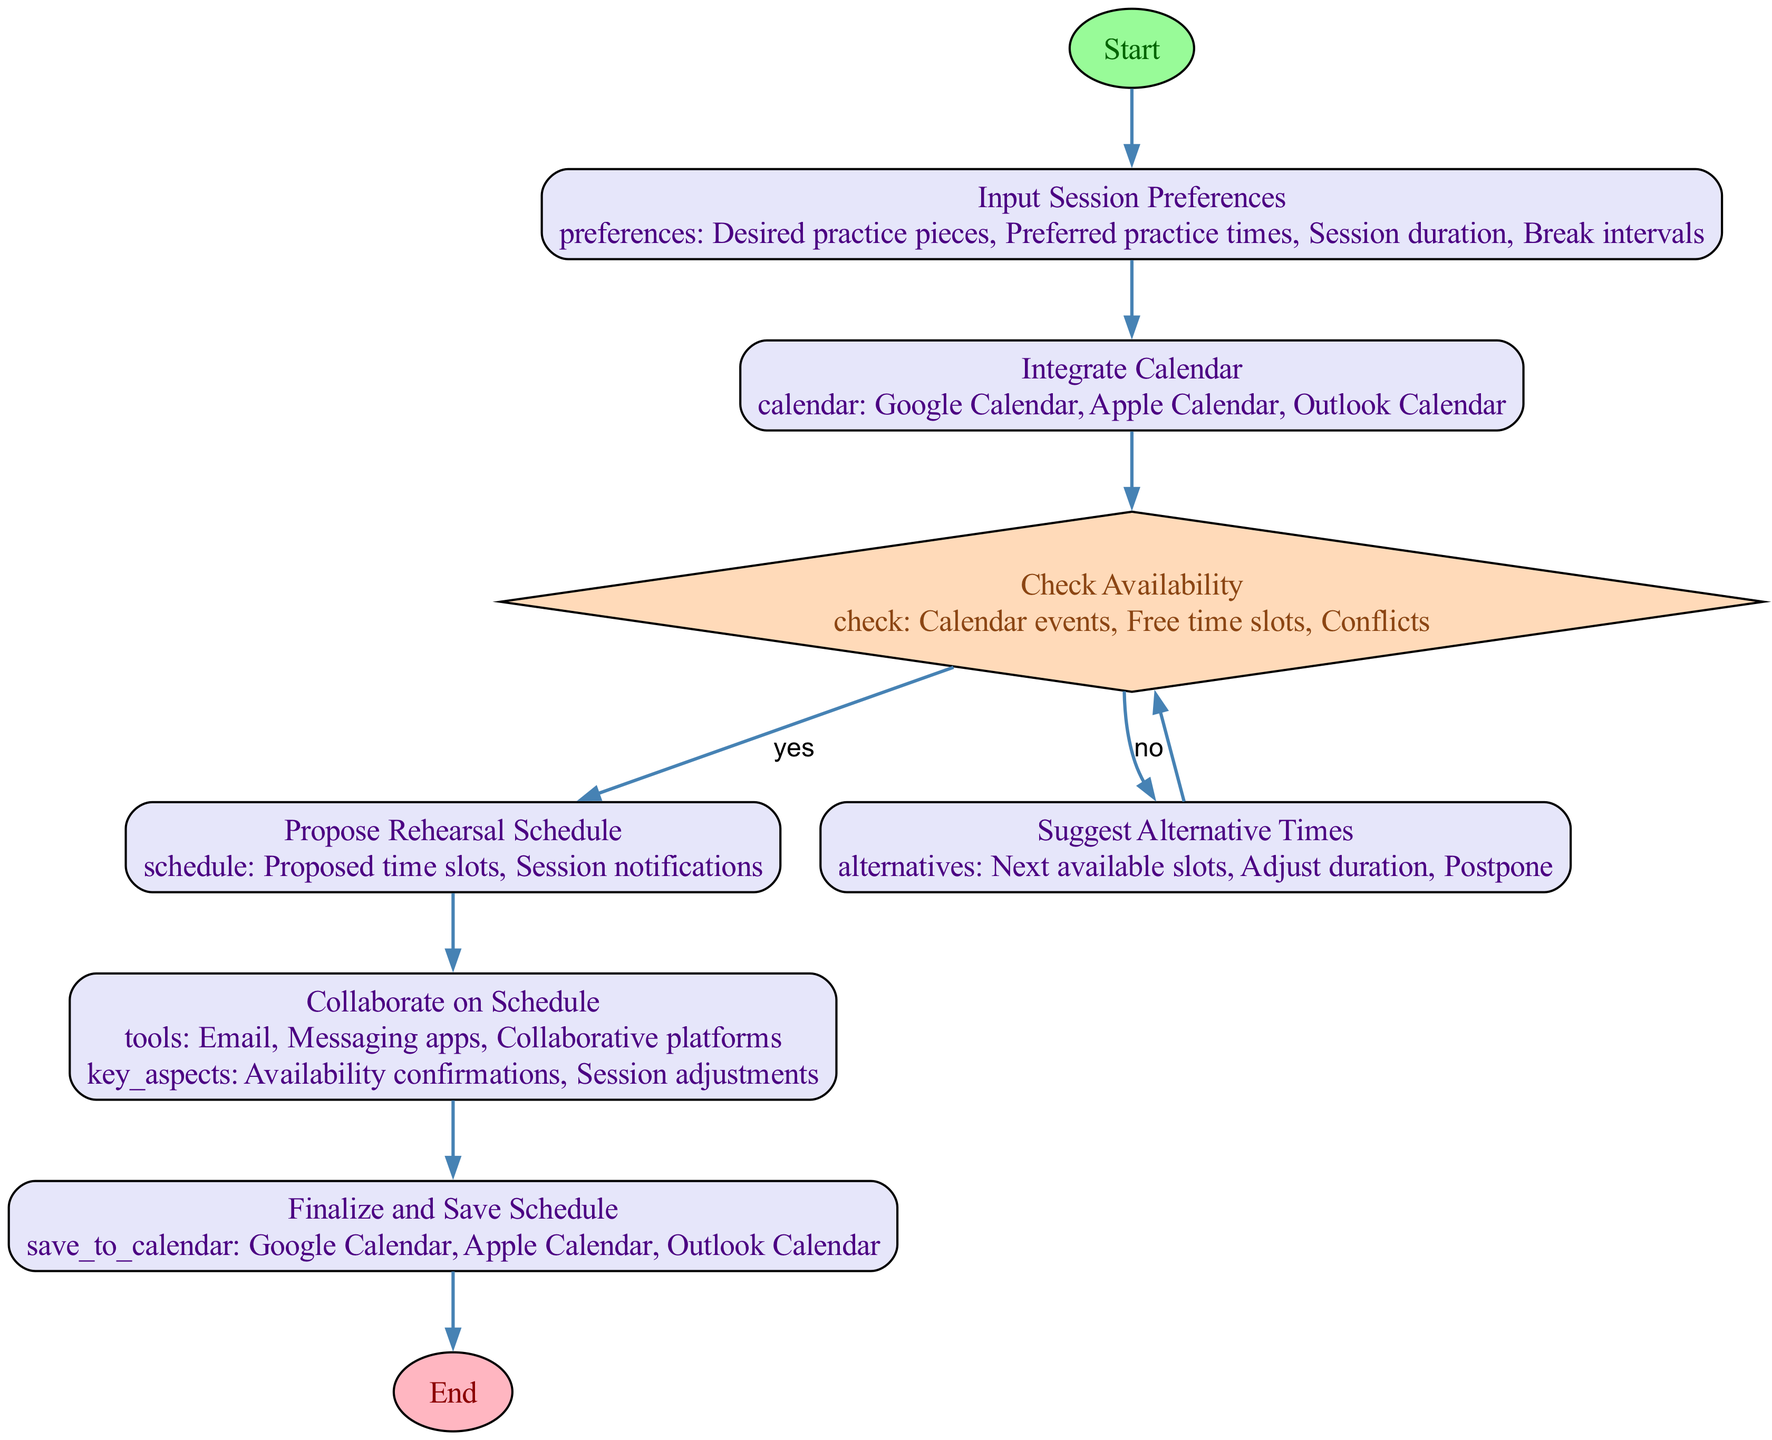What is the first step in the flowchart? The flowchart starts at the "Start" node, which initiates the process.
Answer: Start How many decision nodes are present in the flowchart? There is one decision node, which is "Check Availability."
Answer: 1 Which calendar options are integrated in the flowchart? The flowchart integrates Google Calendar, Apple Calendar, and Outlook Calendar for scheduling.
Answer: Google Calendar, Apple Calendar, Outlook Calendar What happens if there are no available times in the calendar? If there are no available times, the flowchart directs to the "Suggest Alternative Times" process.
Answer: Suggest Alternative Times What is the final step in the rehearsal session planning process? The final step is "End," which signifies the completion of the process.
Answer: End What tools can be used for collaboration on the schedule? The collaboration tools include Email, Messaging apps, and Collaborative platforms.
Answer: Email, Messaging apps, Collaborative platforms What occurs after the "Propose Rehearsal Schedule" process? After "Propose Rehearsal Schedule," the next step is "Collaborate on Schedule."
Answer: Collaborate on Schedule How do you return to "Check Availability" after suggesting alternative times? The flowchart shows that after suggesting alternatives, it loops back to the "Check Availability" decision node.
Answer: Check Availability What are the key aspects of collaboration on the schedule? The key aspects include Availability confirmations and Session adjustments.
Answer: Availability confirmations, Session adjustments 